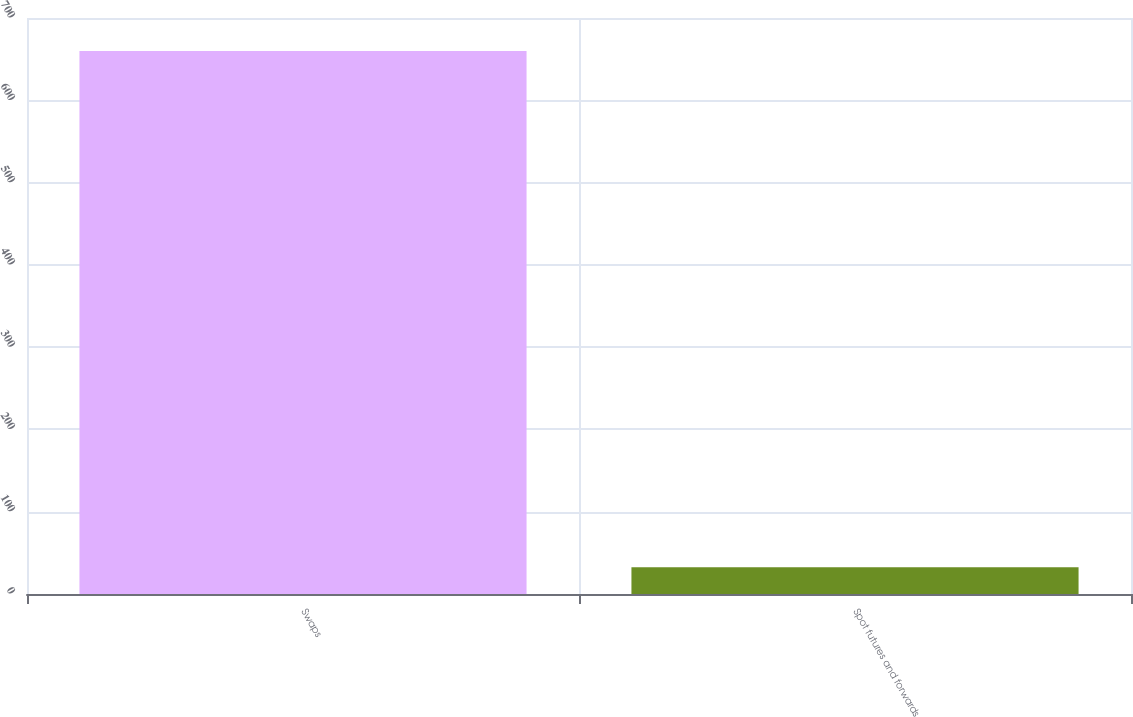Convert chart to OTSL. <chart><loc_0><loc_0><loc_500><loc_500><bar_chart><fcel>Swaps<fcel>Spot futures and forwards<nl><fcel>659.9<fcel>32.5<nl></chart> 